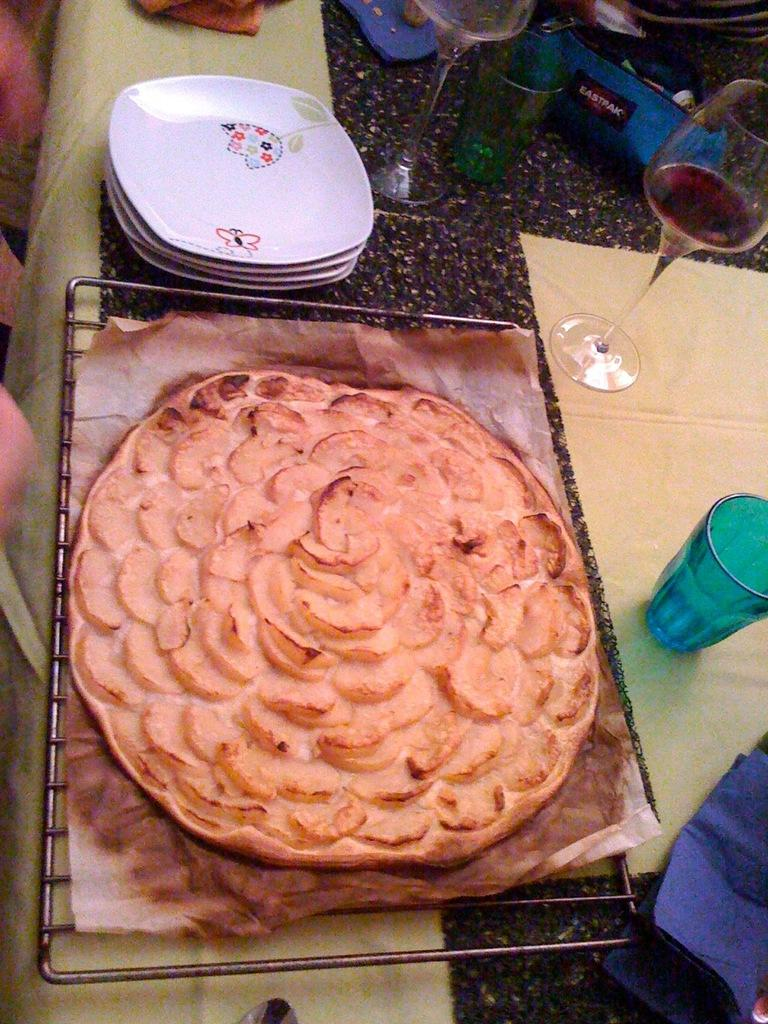What is being cooked on the grill in the image? There is food on a grill in the image. What can be used for serving food in the image? There are plates in the image. What can be used for drinking in the image? There are glasses in the image. What can be used for holding liquids in the image? There are bottles in the image. What can be used for writing or covering in the image? There is paper and a cloth in the image. Where are all these items located in the image? All of these items are placed on a table in the image. What type of rock is being used as a coaster for the glasses in the image? There is no rock being used as a coaster in the image; the glasses are placed on the table. 